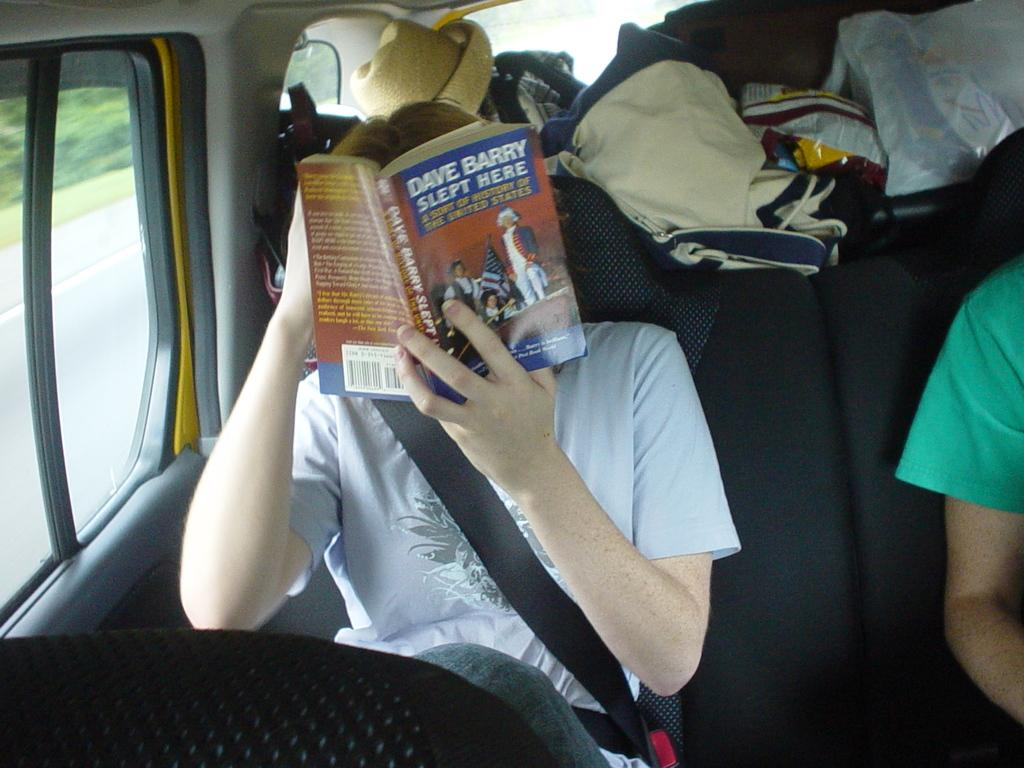<image>
Render a clear and concise summary of the photo. A person is in a car reading a book titled Dave Barry Slept Here. 